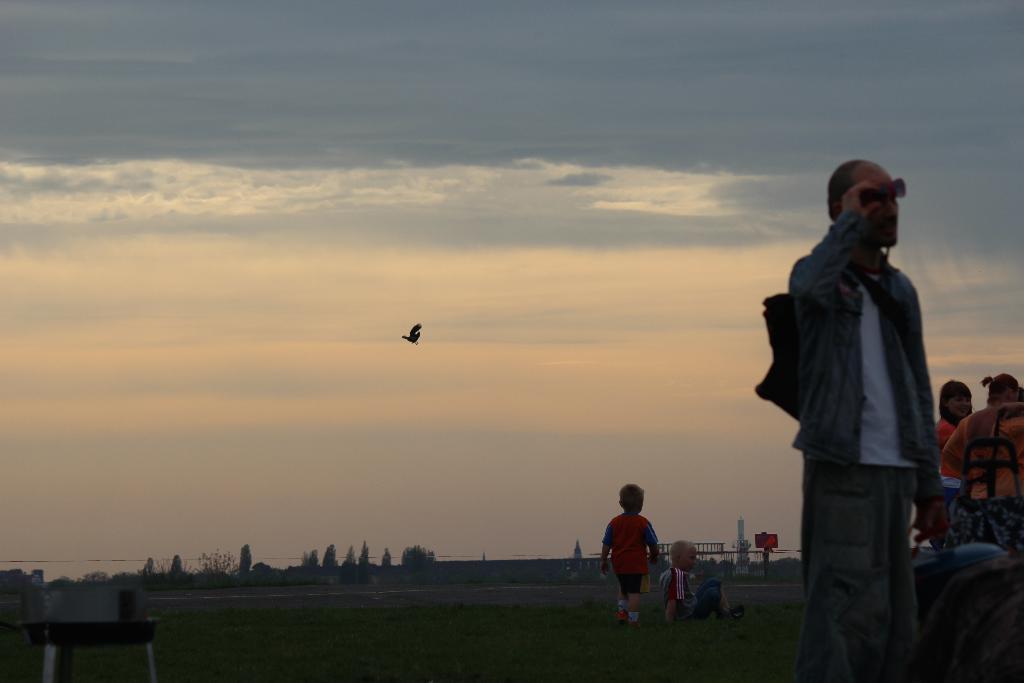In one or two sentences, can you explain what this image depicts? In this image I can see the ground, few persons standing, a child sitting and in the background I can see few trees, a bird flying in the air, a pole with a board attached to it and the sky. 